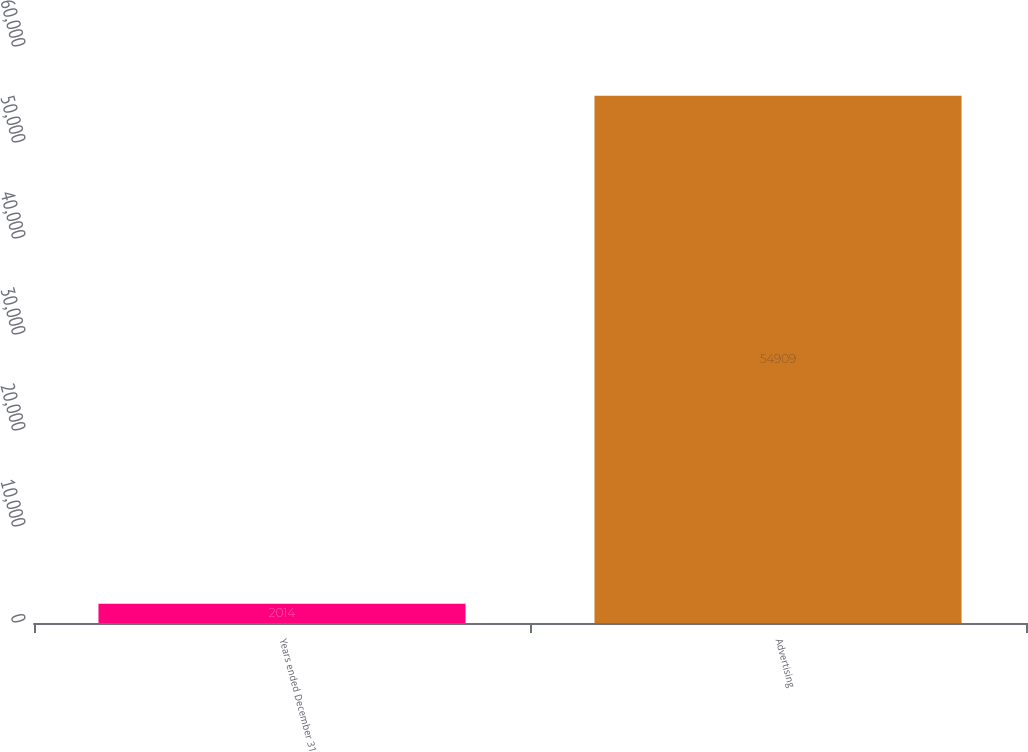Convert chart to OTSL. <chart><loc_0><loc_0><loc_500><loc_500><bar_chart><fcel>Years ended December 31<fcel>Advertising<nl><fcel>2014<fcel>54909<nl></chart> 